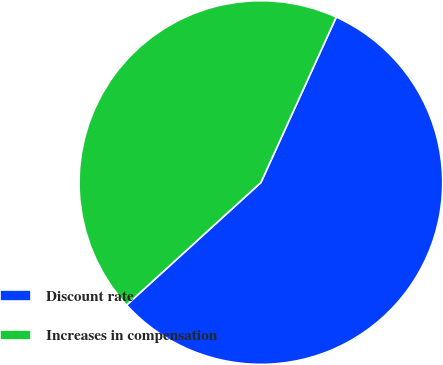<chart> <loc_0><loc_0><loc_500><loc_500><pie_chart><fcel>Discount rate<fcel>Increases in compensation<nl><fcel>56.43%<fcel>43.57%<nl></chart> 